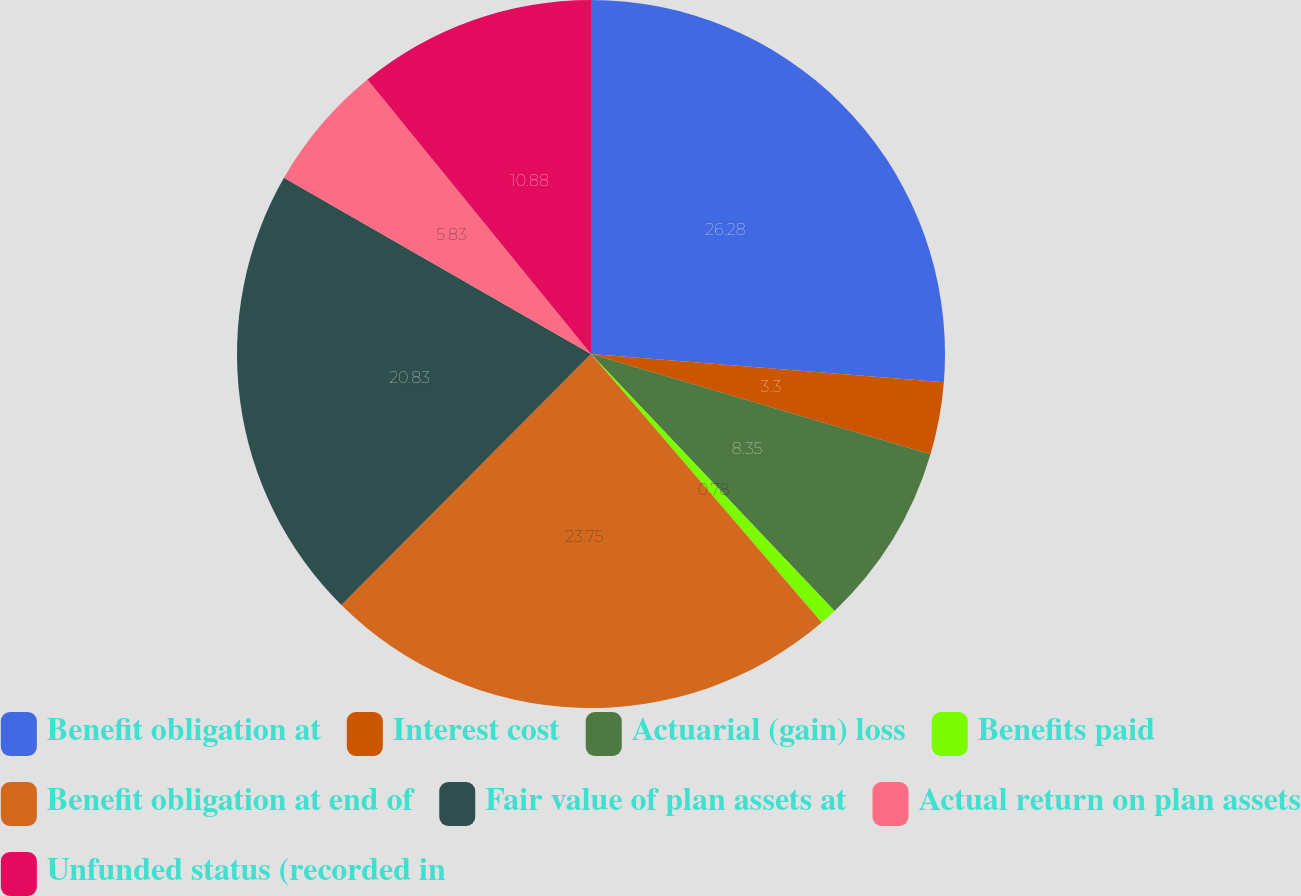Convert chart. <chart><loc_0><loc_0><loc_500><loc_500><pie_chart><fcel>Benefit obligation at<fcel>Interest cost<fcel>Actuarial (gain) loss<fcel>Benefits paid<fcel>Benefit obligation at end of<fcel>Fair value of plan assets at<fcel>Actual return on plan assets<fcel>Unfunded status (recorded in<nl><fcel>26.27%<fcel>3.3%<fcel>8.35%<fcel>0.78%<fcel>23.75%<fcel>20.83%<fcel>5.83%<fcel>10.88%<nl></chart> 